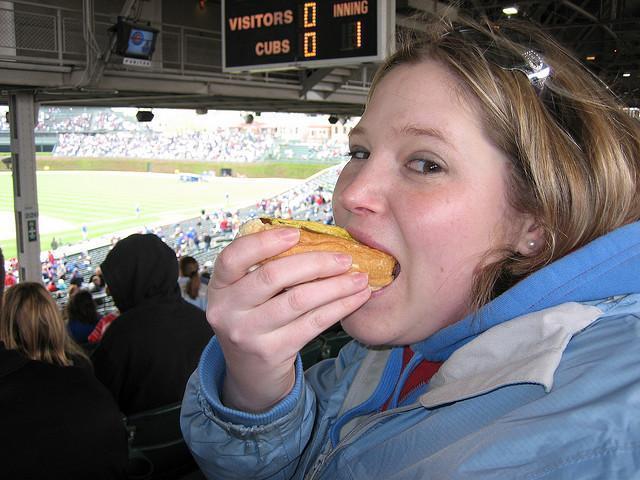The condiment on this food comes from where?
Choose the right answer and clarify with the format: 'Answer: answer
Rationale: rationale.'
Options: Mustard seed, echinacea plant, tomato plant, wasabi leaf. Answer: mustard seed.
Rationale: The food is mustard. 